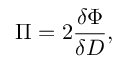Convert formula to latex. <formula><loc_0><loc_0><loc_500><loc_500>\Pi = 2 \frac { \delta \Phi } { \delta D } ,</formula> 